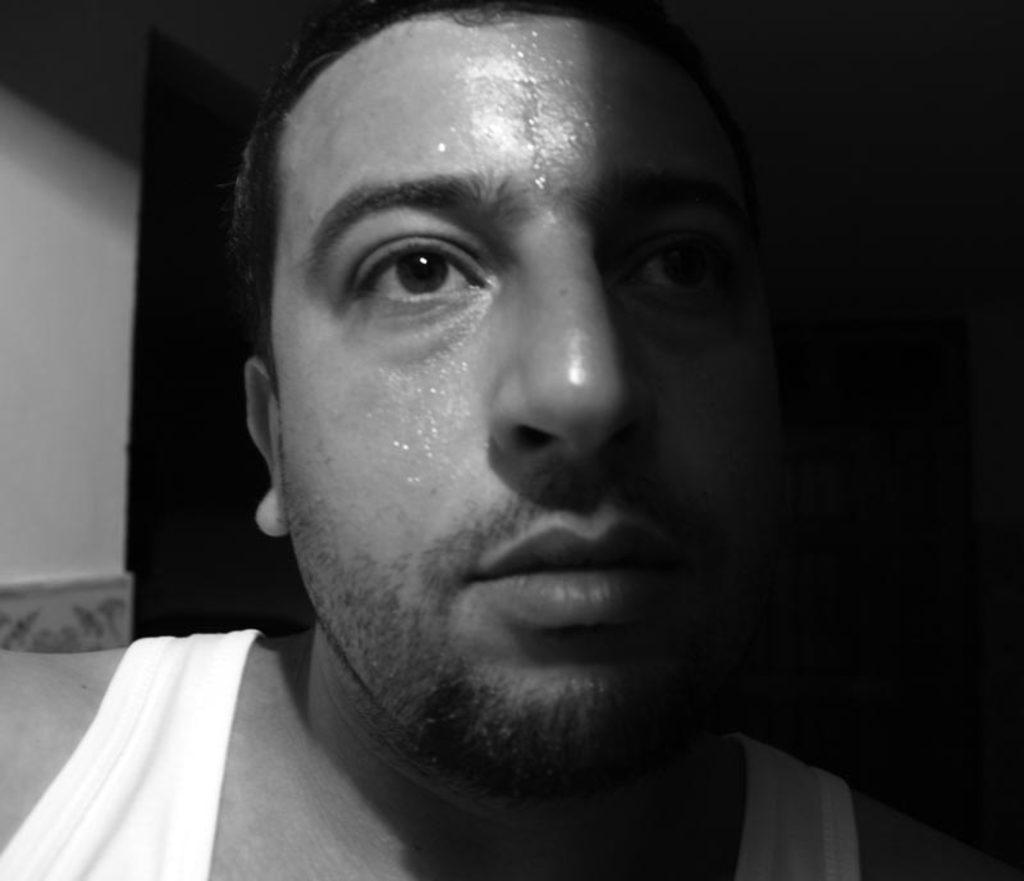Who is present in the image? There is a man in the image. What is the man's physical condition in the image? The man is sweating in the image. What can be seen on the left side of the image? There is a wall on the left side of the image. How would you describe the lighting or color on the right side of the image? The backdrop is dark on the right side of the image. What type of humor can be seen in the image? There is no humor present in the image; it features a man who is sweating. Can you tell me what substance the man is holding in the image? There is no substance visible in the image; the man is not holding anything. 